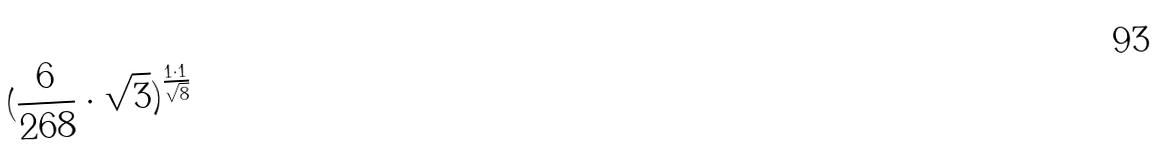<formula> <loc_0><loc_0><loc_500><loc_500>( \frac { 6 } { 2 6 8 } \cdot \sqrt { 3 } ) ^ { \frac { 1 \cdot 1 } { \sqrt { 8 } } }</formula> 